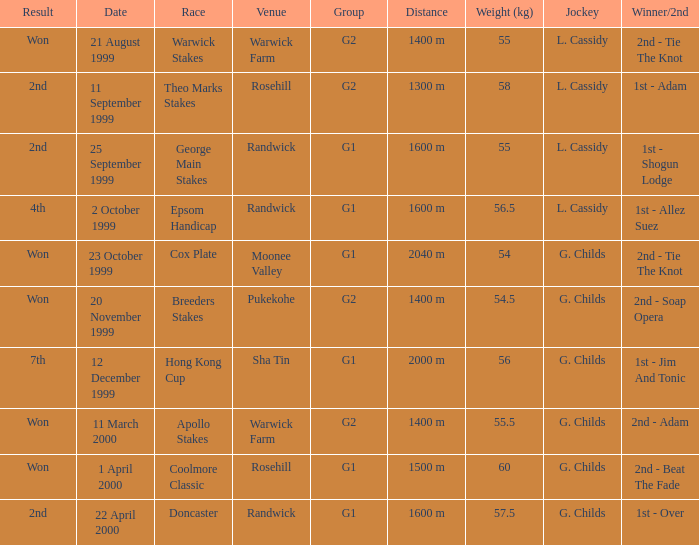Can you provide the weight that corresponds to 56 kilograms? 2000 m. 